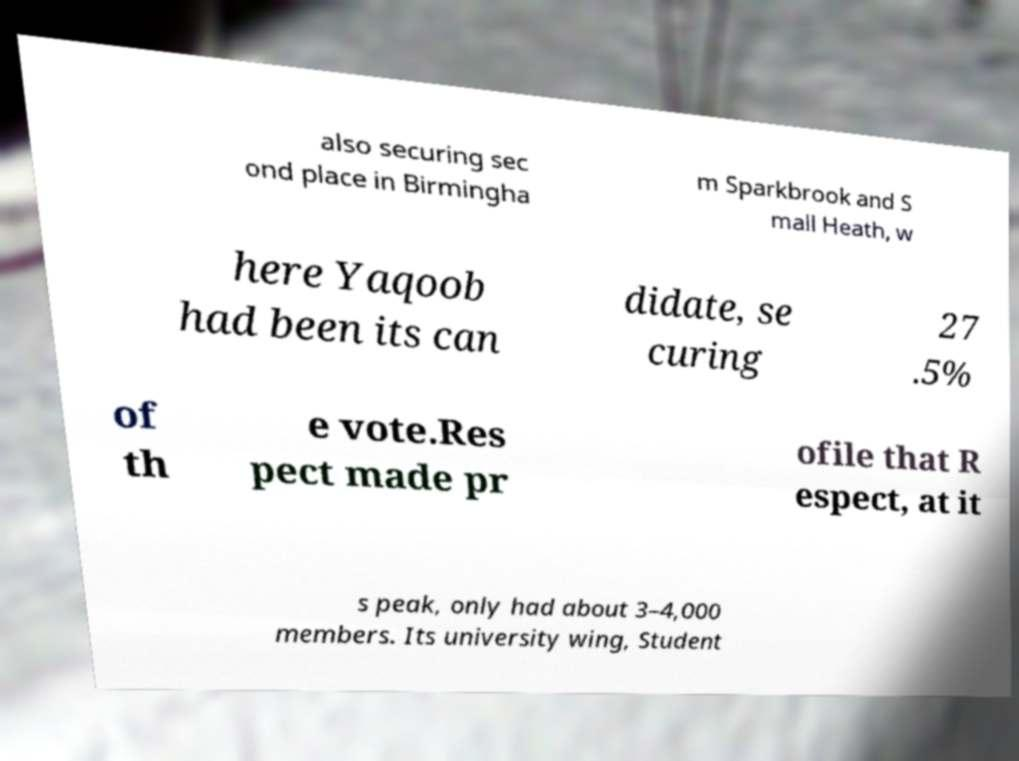Can you read and provide the text displayed in the image?This photo seems to have some interesting text. Can you extract and type it out for me? also securing sec ond place in Birmingha m Sparkbrook and S mall Heath, w here Yaqoob had been its can didate, se curing 27 .5% of th e vote.Res pect made pr ofile that R espect, at it s peak, only had about 3–4,000 members. Its university wing, Student 